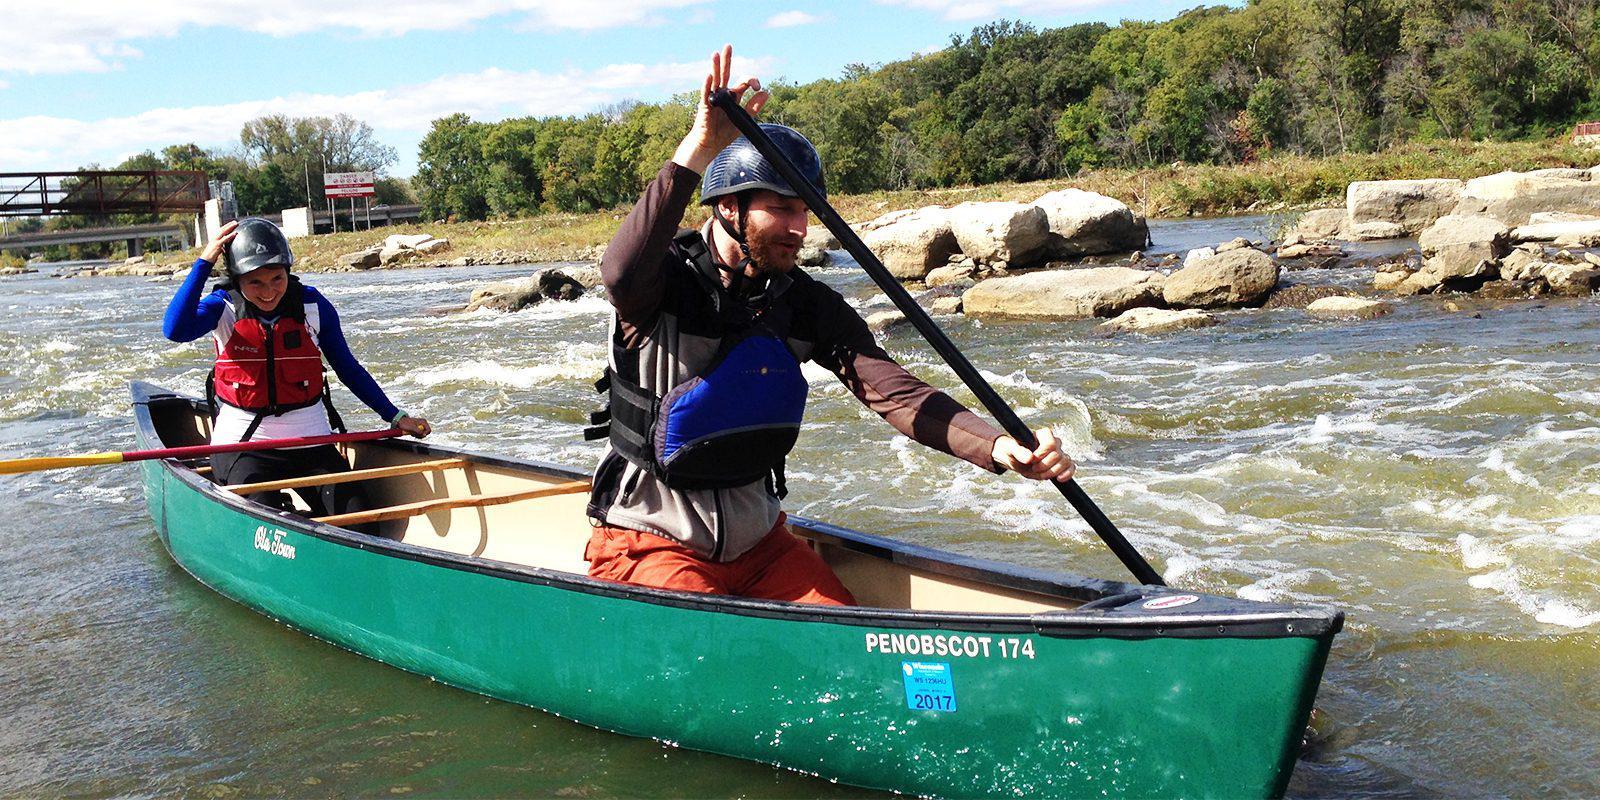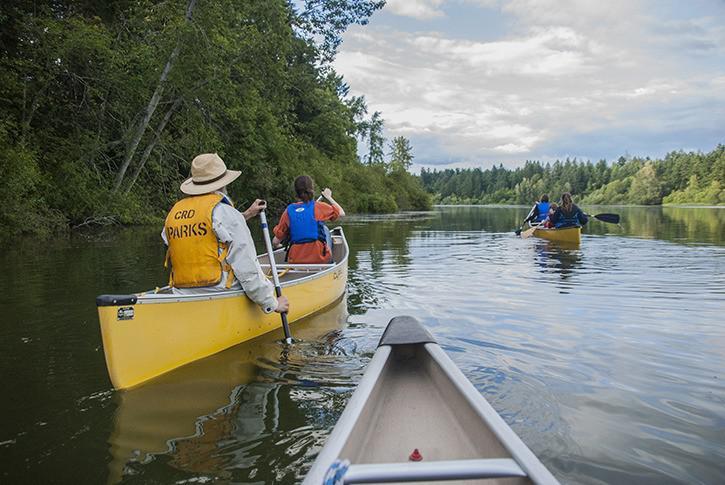The first image is the image on the left, the second image is the image on the right. Considering the images on both sides, is "In at least one image there a at least two red boats on the shore." valid? Answer yes or no. No. The first image is the image on the left, the second image is the image on the right. For the images shown, is this caption "The combined images include several red and yellow boats pulled up on shore." true? Answer yes or no. No. 